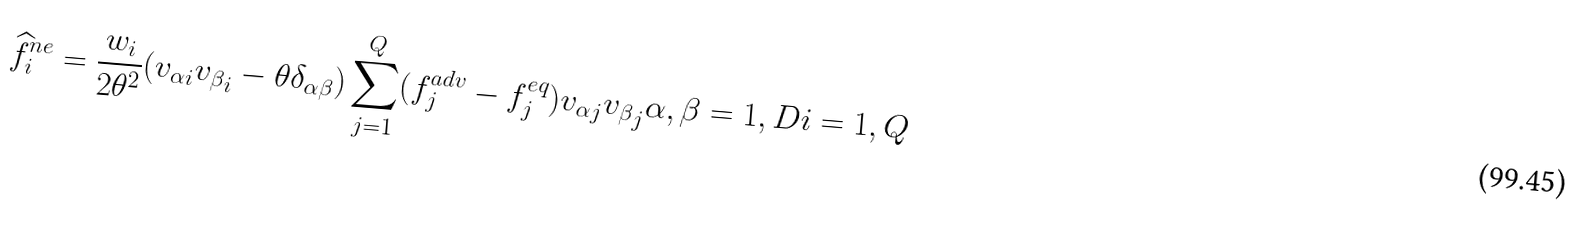<formula> <loc_0><loc_0><loc_500><loc_500>\widehat { f } _ { i } ^ { n e } = \frac { w _ { i } } { 2 \theta ^ { 2 } } ( { v _ { \alpha } } _ { i } { v _ { \beta } } _ { i } - \theta \delta _ { \alpha \beta } ) \sum _ { j = 1 } ^ { Q } ( f _ { j } ^ { a d v } - f _ { j } ^ { e q } ) { v _ { \alpha } } _ { j } { v _ { \beta } } _ { j } \alpha , \beta = 1 , D i = 1 , Q</formula> 